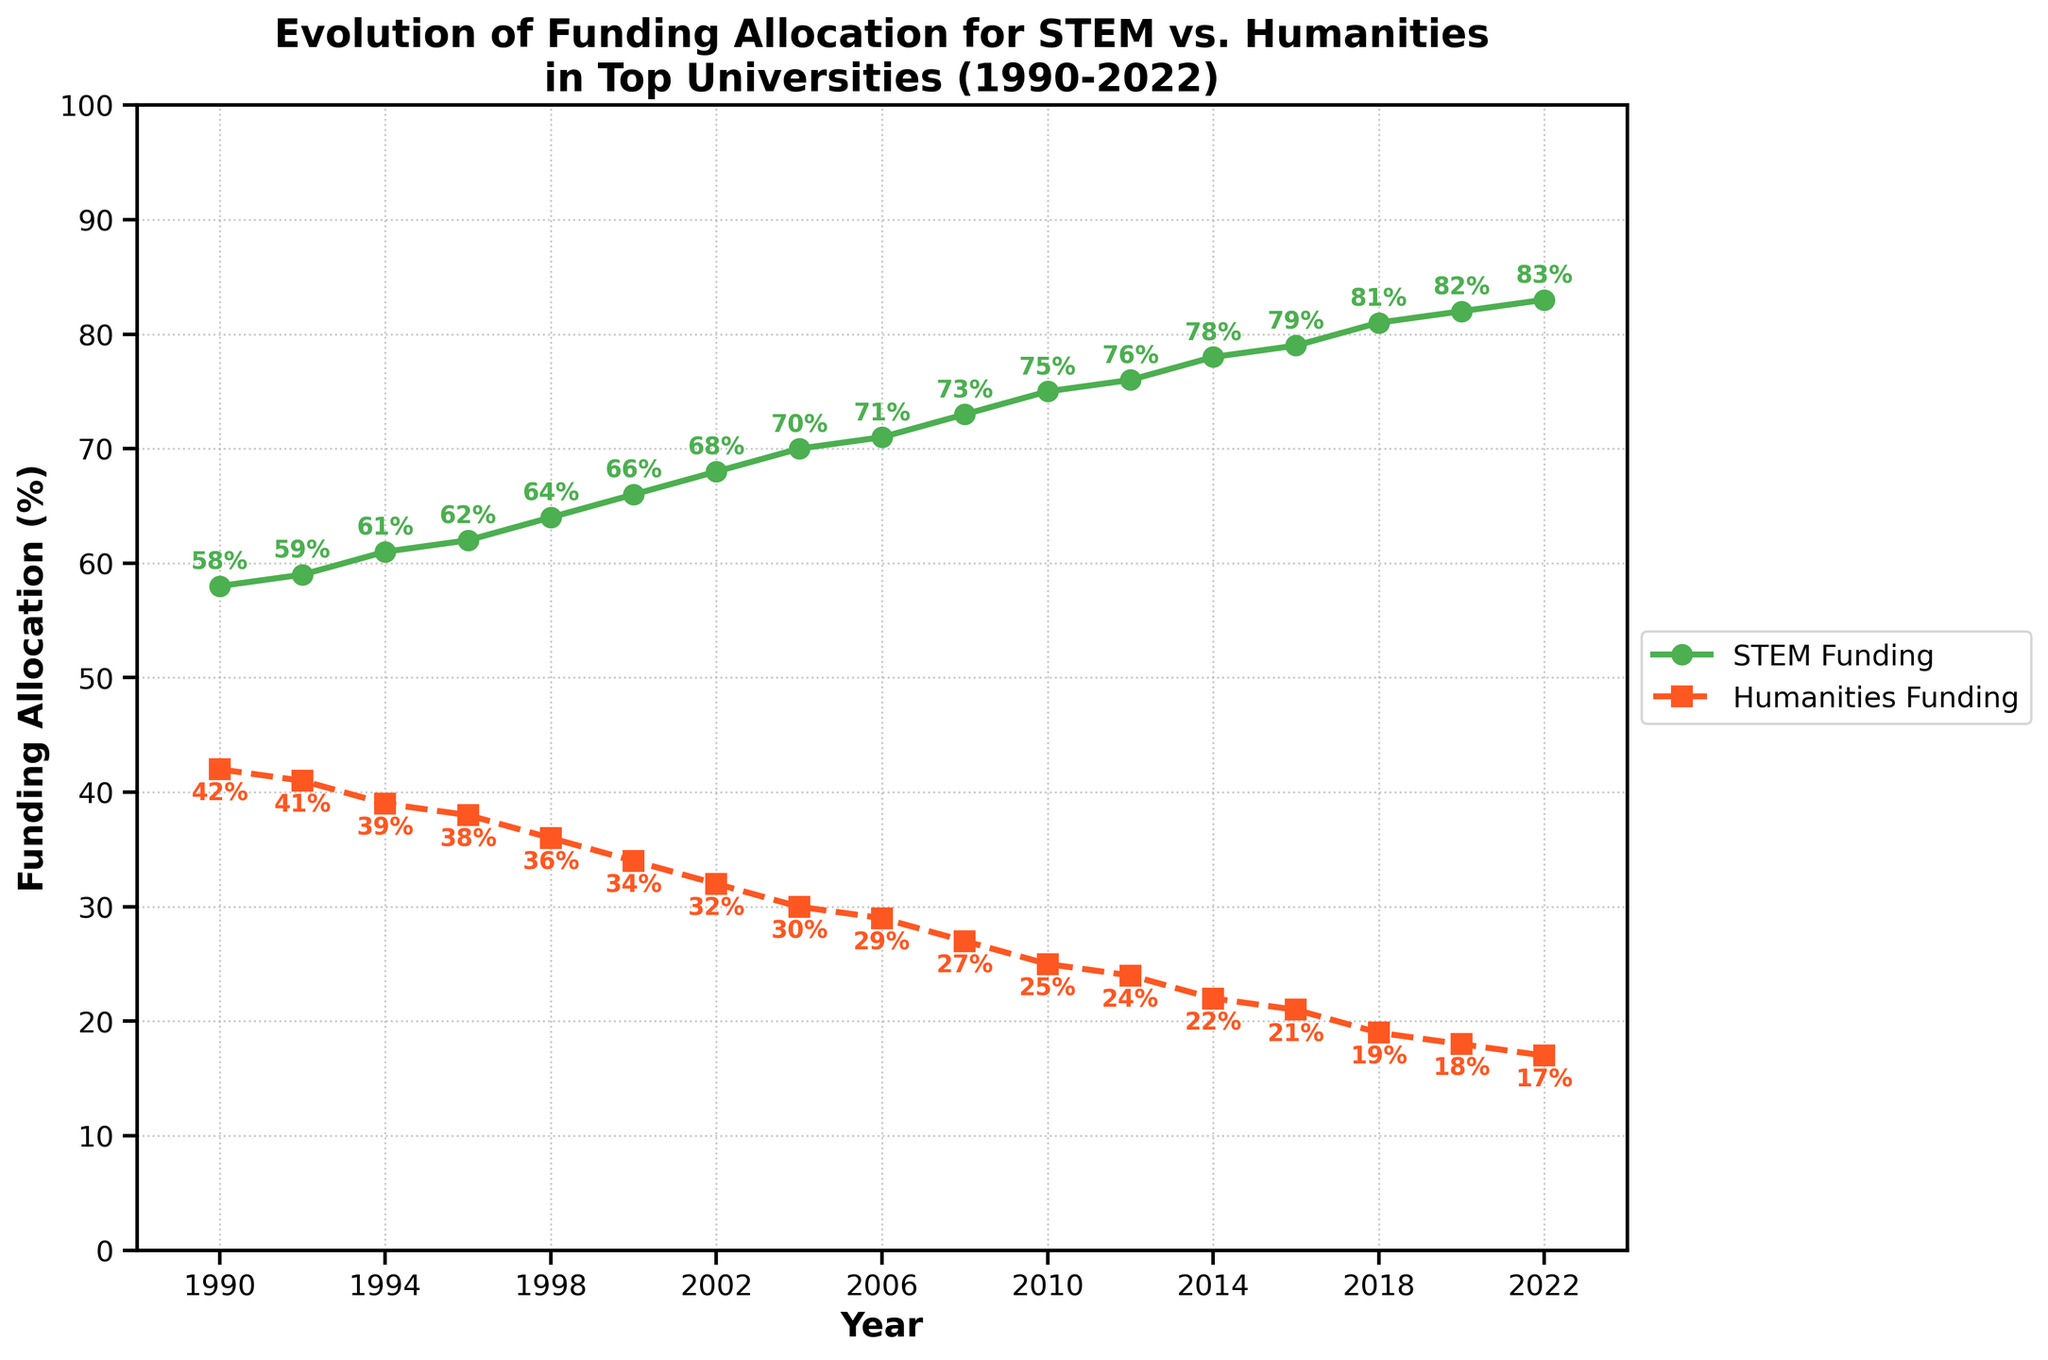What percentage of funding was allocated to STEM disciplines in 2006? Look at the point corresponding to the year 2006 on the green line and read the value.
Answer: 71% What is the combined total percentage of funding for both STEM and Humanities in 1994? Locate the funding values for both disciplines in 1994. STEM is 61% and Humanities is 39%. Add these values: 61% + 39% = 100%.
Answer: 100% How much did the funding for Humanities decrease from 1990 to 2022? Identify the values for Humanities funding for the years 1990 and 2022. Humanities had 42% funding in 1990 and 17% in 2022. Subtract the 2022 value from the 1990 value: 42% - 17% = 25%.
Answer: 25% In which year did STEM funding surpass 70% for the first time? Find the point on the green line where the value first exceeds 70%. The value is 70% in 2004, and it remains above 70% in subsequent years.
Answer: 2006 Which discipline received more consistent funding over the years: STEM or Humanities? Compare the smoothness and trend of both lines. The STEM line consistently increases while the Humanities line consistently decreases, indicating STEM funding has a more consistent upward trend and Humanities a consistent downward trend.
Answer: Both Between which consecutive years did STEM funding see the highest increase? Examine all the yearly increments of STEM funding and identify the largest. From 1998-2000: an increase from 64% to 66% (2%). From 2000-2002: an increase from 66% to 68% (2%). From 2002-2004: an increase from 68% to 70% (2%). From 2004-2006: an increase from 70% to 71% (1%). From 2006-2008: an increase from 71% to 73% (2%). From 2008-2010: an increase from 73% to 75% (2%). From 2010-2012: an increase from 75% to 76% (1%). From 2012-2014: an increase from 76% to 78% (2%). From 2014-2016: an increase from 78% to 79% (1%). From 2016-2018: an increase from 79% to 81% (2%). From 2018-2020: an increase from 81% to 82% (1%). From 2020-2022: an increase from 82% to 83% (1%). Therefore, the highest increase is seen in multiple intervals with a 2% increase, including 1998-2000, 2000-2002, 2002-2004, 2006-2008, 2008-2010, 2012-2014, 2016-2018.
Answer: 1998-2000, 2000-2002, 2002-2004, 2006-2008, 2008-2010, 2012-2014, 2016-2018 What are the two disciplines compared in the chart, and how are they visually distinguished? The chart compares STEM and Humanities funding. The STEM funding is represented by a green line with circle markers, and Humanities funding is shown as a red dashed line with square markers.
Answer: STEM (green line), Humanities (red dashed line) What is the difference in STEM funding between the years 2010 and 2020? Identify the values for STEM funding in 2010 (75%) and 2020 (82%). Subtract the 2010 value from the 2020 value: 82% - 75% = 7%.
Answer: 7% By how much did Humanities funding change between 1992 and 2022? Identify Humanities funding values for the years 1992 (41%) and 2022 (17%). Calculate the difference: 41% - 17% = 24%.
Answer: 24% What trend do you observe in the funding allocation for STEM and Humanities from 1990 to 2022? Observe the overall direction of both lines. STEM funding is increasing steadily, while Humanities funding is decreasing steadily.
Answer: STEM increases, Humanities decreases 